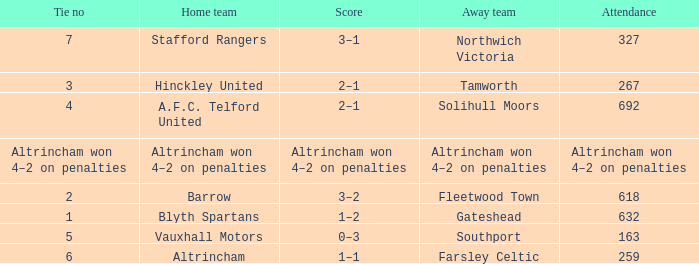What was the score when there were 7 ties? 3–1. Give me the full table as a dictionary. {'header': ['Tie no', 'Home team', 'Score', 'Away team', 'Attendance'], 'rows': [['7', 'Stafford Rangers', '3–1', 'Northwich Victoria', '327'], ['3', 'Hinckley United', '2–1', 'Tamworth', '267'], ['4', 'A.F.C. Telford United', '2–1', 'Solihull Moors', '692'], ['Altrincham won 4–2 on penalties', 'Altrincham won 4–2 on penalties', 'Altrincham won 4–2 on penalties', 'Altrincham won 4–2 on penalties', 'Altrincham won 4–2 on penalties'], ['2', 'Barrow', '3–2', 'Fleetwood Town', '618'], ['1', 'Blyth Spartans', '1–2', 'Gateshead', '632'], ['5', 'Vauxhall Motors', '0–3', 'Southport', '163'], ['6', 'Altrincham', '1–1', 'Farsley Celtic', '259']]} 